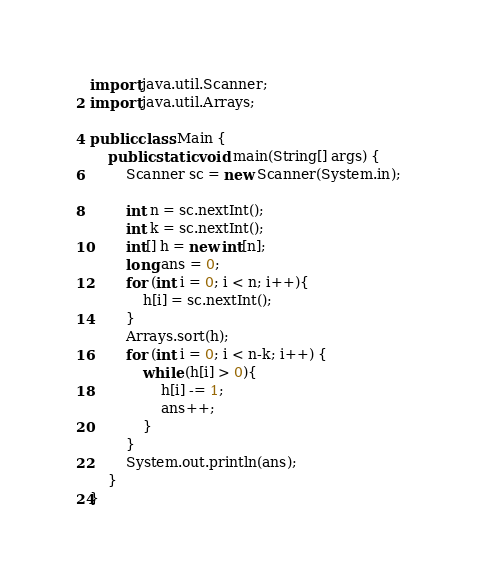Convert code to text. <code><loc_0><loc_0><loc_500><loc_500><_Java_>import java.util.Scanner;
import java.util.Arrays;

public class Main {
	public static void main(String[] args) {
		Scanner sc = new Scanner(System.in);

		int n = sc.nextInt();
		int k = sc.nextInt();
		int[] h = new int[n];
		long ans = 0;
		for (int i = 0; i < n; i++){
			h[i] = sc.nextInt();
		}
		Arrays.sort(h);
		for (int i = 0; i < n-k; i++) {
			while (h[i] > 0){
				h[i] -= 1;
				ans++;
			}
		}
		System.out.println(ans);
	}
}</code> 